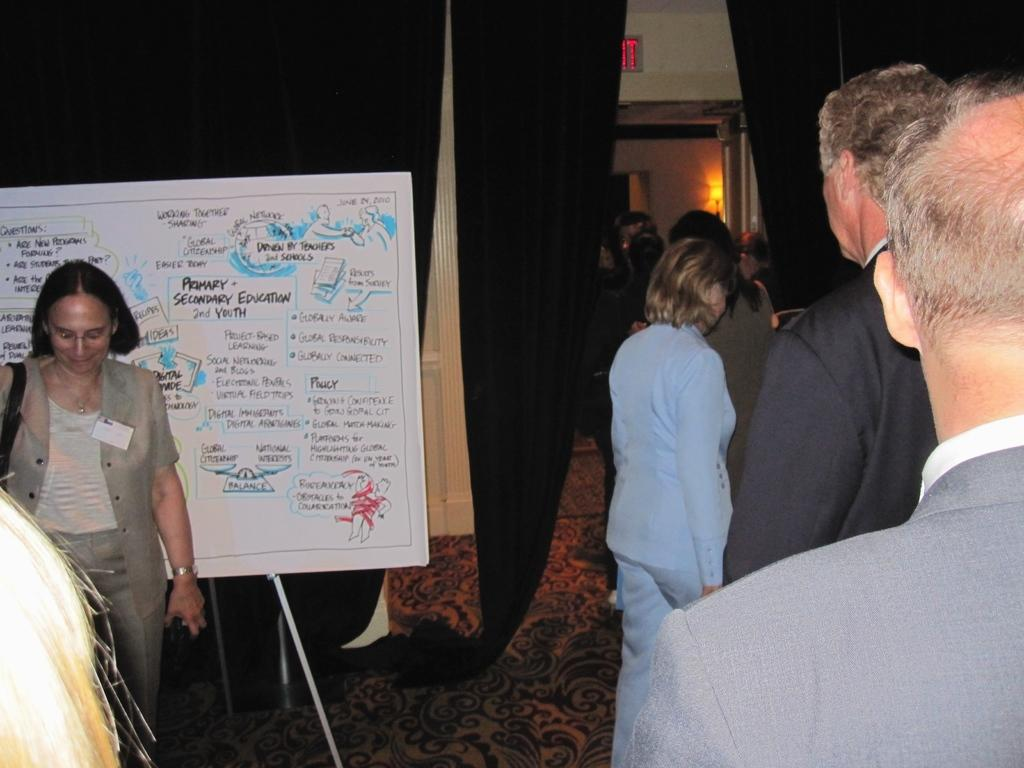How many people are in the image? There is a group of people in the image, but the exact number is not specified. What is the position of the people in the image? The people are standing on the floor in the image. What objects can be seen in the image besides the people? There is a board, a stand, curtains, a wall, a door, and lights visible in the image. What type of room might the image have been taken in? The image may have been taken in a hall, based on the presence of a board, stand, and curtains. What type of bird is perched on the door in the image? There is no bird present on the door in the image. What type of crook is holding the board in the image? There is no crook present in the image, and the board is not being held by anyone. 